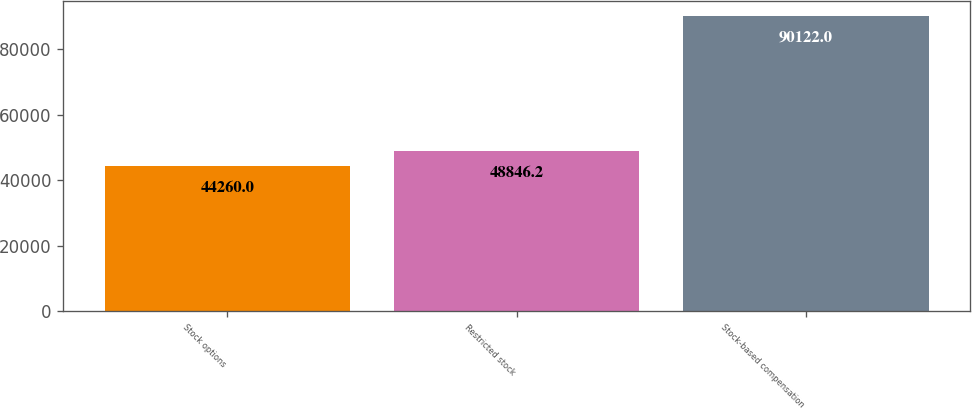<chart> <loc_0><loc_0><loc_500><loc_500><bar_chart><fcel>Stock options<fcel>Restricted stock<fcel>Stock-based compensation<nl><fcel>44260<fcel>48846.2<fcel>90122<nl></chart> 